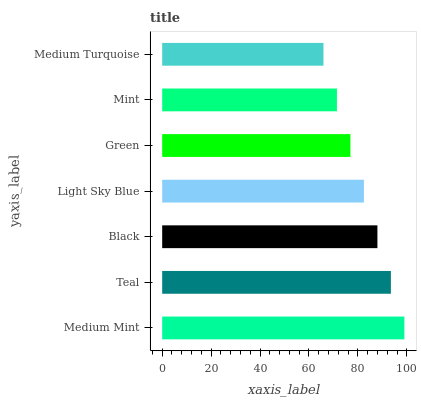Is Medium Turquoise the minimum?
Answer yes or no. Yes. Is Medium Mint the maximum?
Answer yes or no. Yes. Is Teal the minimum?
Answer yes or no. No. Is Teal the maximum?
Answer yes or no. No. Is Medium Mint greater than Teal?
Answer yes or no. Yes. Is Teal less than Medium Mint?
Answer yes or no. Yes. Is Teal greater than Medium Mint?
Answer yes or no. No. Is Medium Mint less than Teal?
Answer yes or no. No. Is Light Sky Blue the high median?
Answer yes or no. Yes. Is Light Sky Blue the low median?
Answer yes or no. Yes. Is Medium Turquoise the high median?
Answer yes or no. No. Is Teal the low median?
Answer yes or no. No. 